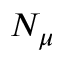<formula> <loc_0><loc_0><loc_500><loc_500>N _ { \mu }</formula> 